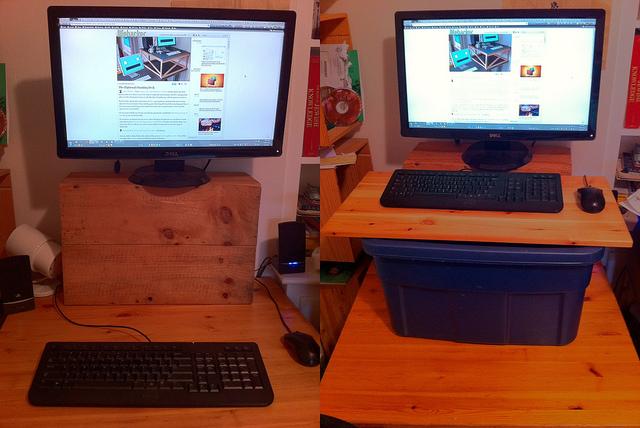What is the difference between the position of the monitors?
Write a very short answer. None. What color is the bucket?
Short answer required. Blue. Are the keyboards wireless?
Keep it brief. No. 